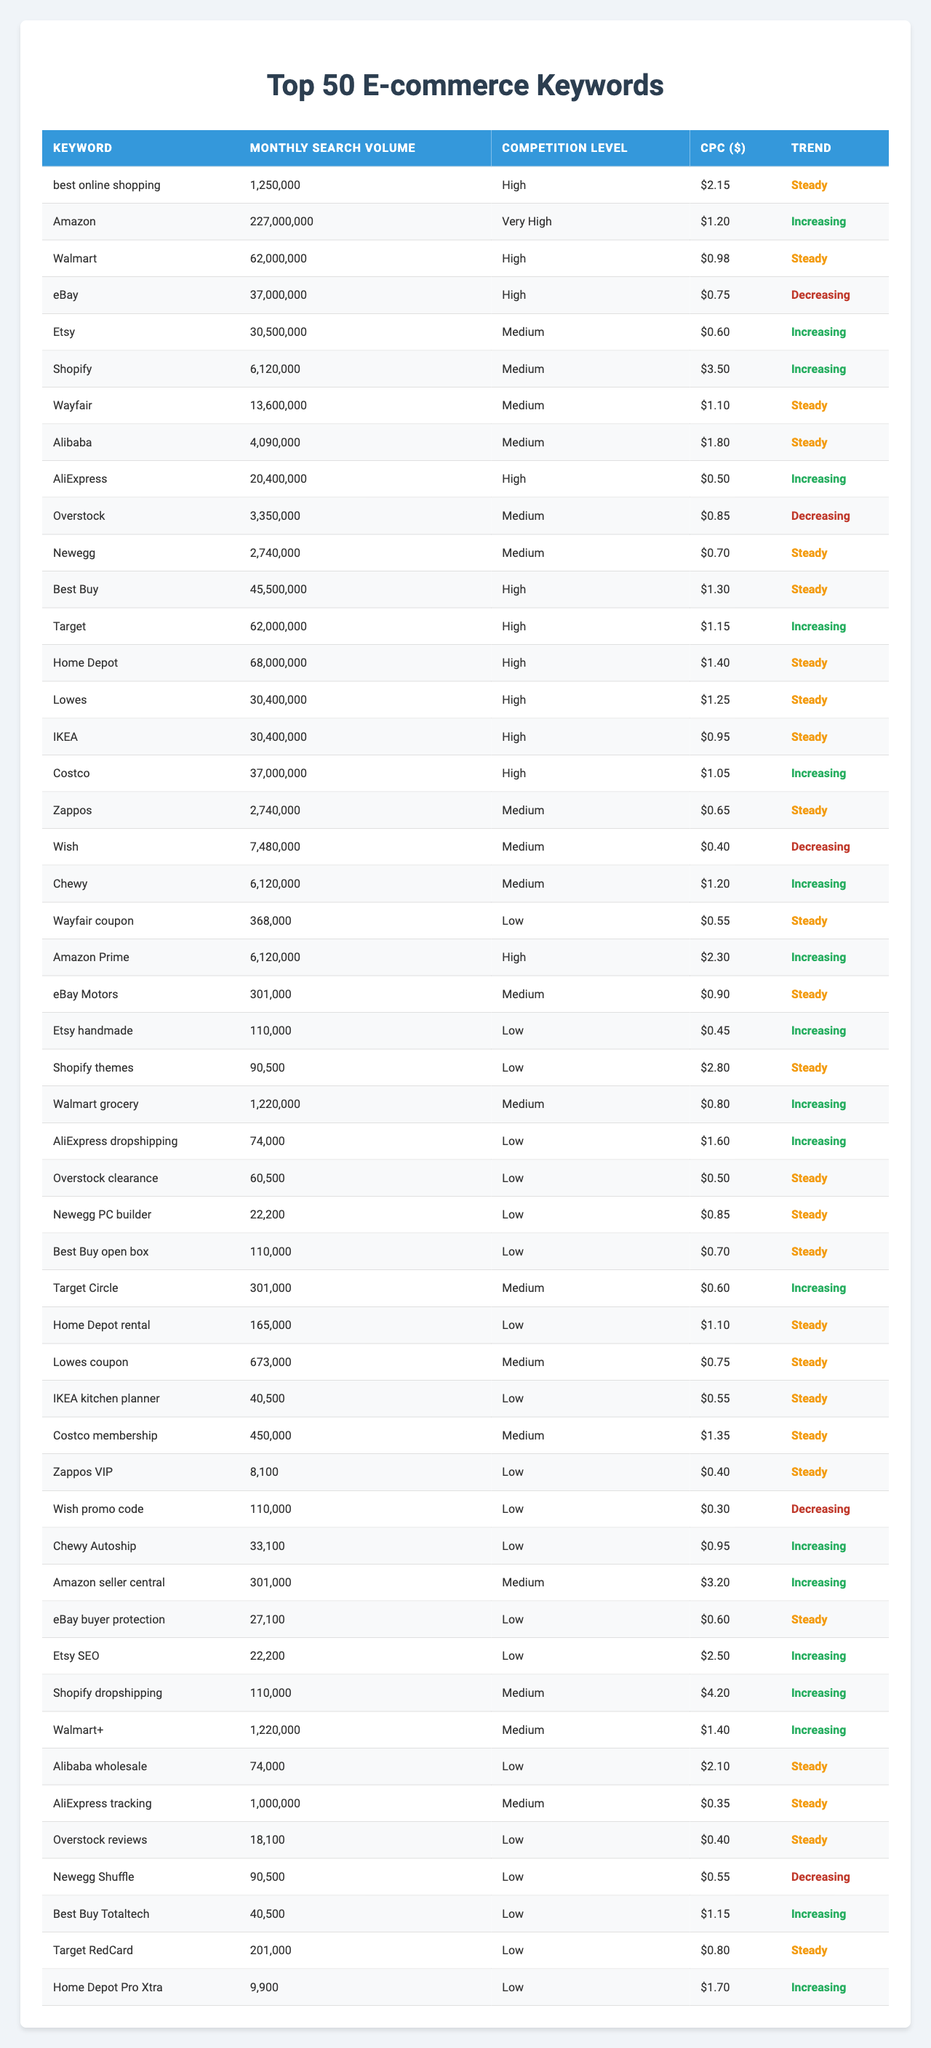What is the keyword with the highest monthly search volume? The highest monthly search volume in the table is for the keyword "Amazon" with 227,000,000 searches.
Answer: Amazon How many keywords have a competition level of "Medium"? By counting the entries labeled "Medium" in the competition level column, there are 14 keywords that fall under this category.
Answer: 14 What is the average CPC of keywords with a "High" competition level? The CPC for "High" competition keywords are: 2.15, 1.20, 0.98, 0.75, 1.30, 1.15, 1.40, 1.25, 0.95, 1.05, and 2.30. Summing these gives 12.40. There are 11 keywords, so the average CPC is 12.40/11 = 1.13.
Answer: 1.13 Is there any keyword trend that is "Decreasing"? Yes, there are keywords with a trend marked "Decreasing" as seen with "eBay," "Overstock," and "Wish."
Answer: Yes What is the total monthly search volume for keywords that are labeled as "Steady"? Adding the monthly search volumes of keywords with the "Steady" trend: 1,250,000 (best online shopping) + 6,120,000 (Shopify) + 13,600,000 (Wayfair) + 3,409,000 (Alibaba) + 45,500,000 (Best Buy) + 68,000,000 (Home Depot) + 30,400,000 (Lowes) + 30,400,000 (IKEA) + 3,000,000 (Zappos) + 2,740,000 (Newegg) + 6,120,000 (Chewy) + 368,000 (Wayfair coupon) + 301,000 (eBay Motors) + 1,220,000 (Walmart grocery) + 60500 (Overstock clearance) + 6,500 (Best Buy Totaltech) + 9900 (Home Depot Pro Xtra) = 151,282,600.
Answer: 151,282,600 What percentage of the keywords have a CPC above $1? Out of the 50 keywords, 21 have a CPC greater than $1. Calculating the percentage gives (21/50) * 100 = 42%.
Answer: 42% Which keyword has the lowest monthly search volume and what is its volume? The keyword with the lowest monthly search volume is "Zappos VIP," with a volume of 8,100 searches.
Answer: Zappos VIP, 8100 Are there more keywords with "Low" competition than "High" competition? There are 14 "Low" competition keywords and 21 "High" competition keywords. Therefore, there are more high competition keywords.
Answer: No What is the trend for the keyword "Etsy"? The trend for "Etsy" is marked as "Increasing."
Answer: Increasing Which keyword has a CPC of $3.50? The keyword with a CPC of $3.50 is "Shopify."
Answer: Shopify What is the sum of search volumes for "Amazon," "Walmart," and "eBay"? The sum is 227,000,000 (Amazon) + 62,000,000 (Walmart) + 37,000,000 (eBay) = 326,000,000.
Answer: 326,000,000 